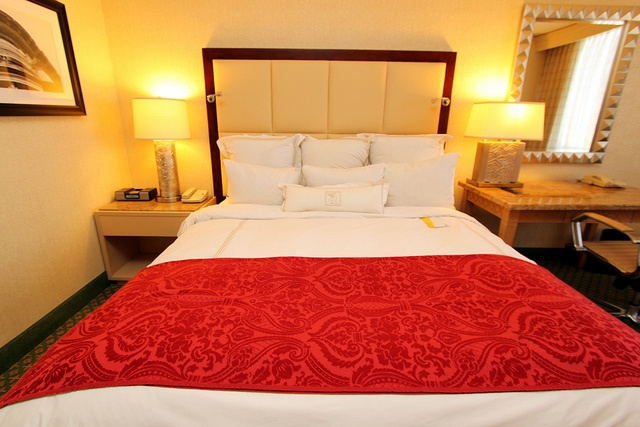Describe the objects in this image and their specific colors. I can see bed in tan, red, brown, and orange tones, chair in tan, black, brown, and maroon tones, and clock in tan, brown, black, maroon, and orange tones in this image. 